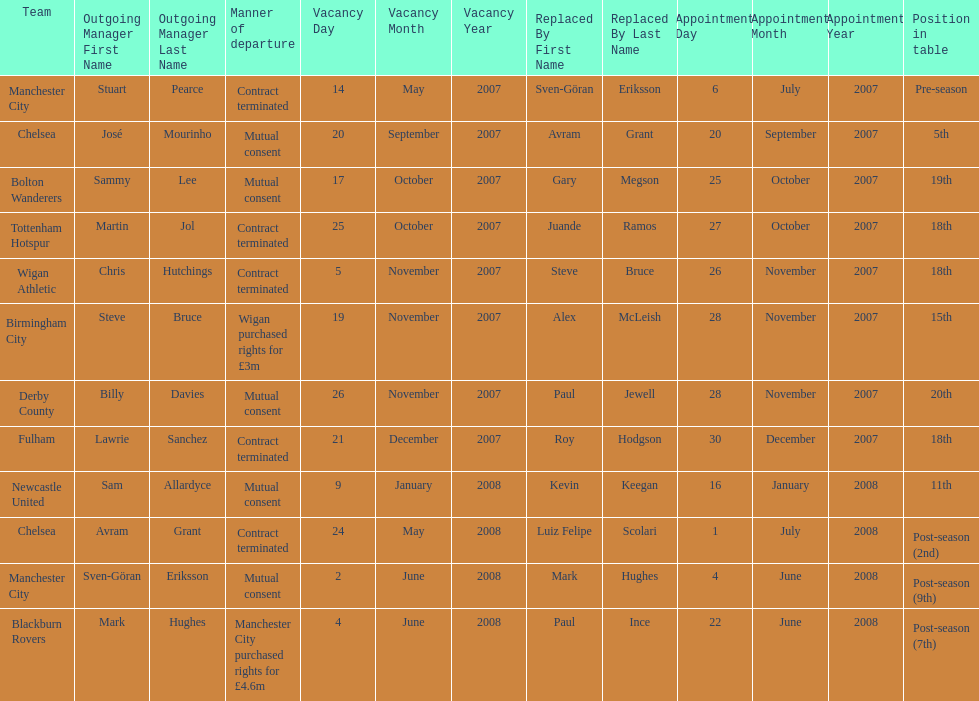What team is listed after manchester city? Chelsea. Write the full table. {'header': ['Team', 'Outgoing Manager First Name', 'Outgoing Manager Last Name', 'Manner of departure', 'Vacancy Day', 'Vacancy Month', 'Vacancy Year', 'Replaced By First Name', 'Replaced By Last Name', 'Appointment Day', 'Appointment Month', 'Appointment Year', 'Position in table'], 'rows': [['Manchester City', 'Stuart', 'Pearce', 'Contract terminated', '14', 'May', '2007', 'Sven-Göran', 'Eriksson', '6', 'July', '2007', 'Pre-season'], ['Chelsea', 'José', 'Mourinho', 'Mutual consent', '20', 'September', '2007', 'Avram', 'Grant', '20', 'September', '2007', '5th'], ['Bolton Wanderers', 'Sammy', 'Lee', 'Mutual consent', '17', 'October', '2007', 'Gary', 'Megson', '25', 'October', '2007', '19th'], ['Tottenham Hotspur', 'Martin', 'Jol', 'Contract terminated', '25', 'October', '2007', 'Juande', 'Ramos', '27', 'October', '2007', '18th'], ['Wigan Athletic', 'Chris', 'Hutchings', 'Contract terminated', '5', 'November', '2007', 'Steve', 'Bruce', '26', 'November', '2007', '18th'], ['Birmingham City', 'Steve', 'Bruce', 'Wigan purchased rights for £3m', '19', 'November', '2007', 'Alex', 'McLeish', '28', 'November', '2007', '15th'], ['Derby County', 'Billy', 'Davies', 'Mutual consent', '26', 'November', '2007', 'Paul', 'Jewell', '28', 'November', '2007', '20th'], ['Fulham', 'Lawrie', 'Sanchez', 'Contract terminated', '21', 'December', '2007', 'Roy', 'Hodgson', '30', 'December', '2007', '18th'], ['Newcastle United', 'Sam', 'Allardyce', 'Mutual consent', '9', 'January', '2008', 'Kevin', 'Keegan', '16', 'January', '2008', '11th'], ['Chelsea', 'Avram', 'Grant', 'Contract terminated', '24', 'May', '2008', 'Luiz Felipe', 'Scolari', '1', 'July', '2008', 'Post-season (2nd)'], ['Manchester City', 'Sven-Göran', 'Eriksson', 'Mutual consent', '2', 'June', '2008', 'Mark', 'Hughes', '4', 'June', '2008', 'Post-season (9th)'], ['Blackburn Rovers', 'Mark', 'Hughes', 'Manchester City purchased rights for £4.6m', '4', 'June', '2008', 'Paul', 'Ince', '22', 'June', '2008', 'Post-season (7th)']]} 